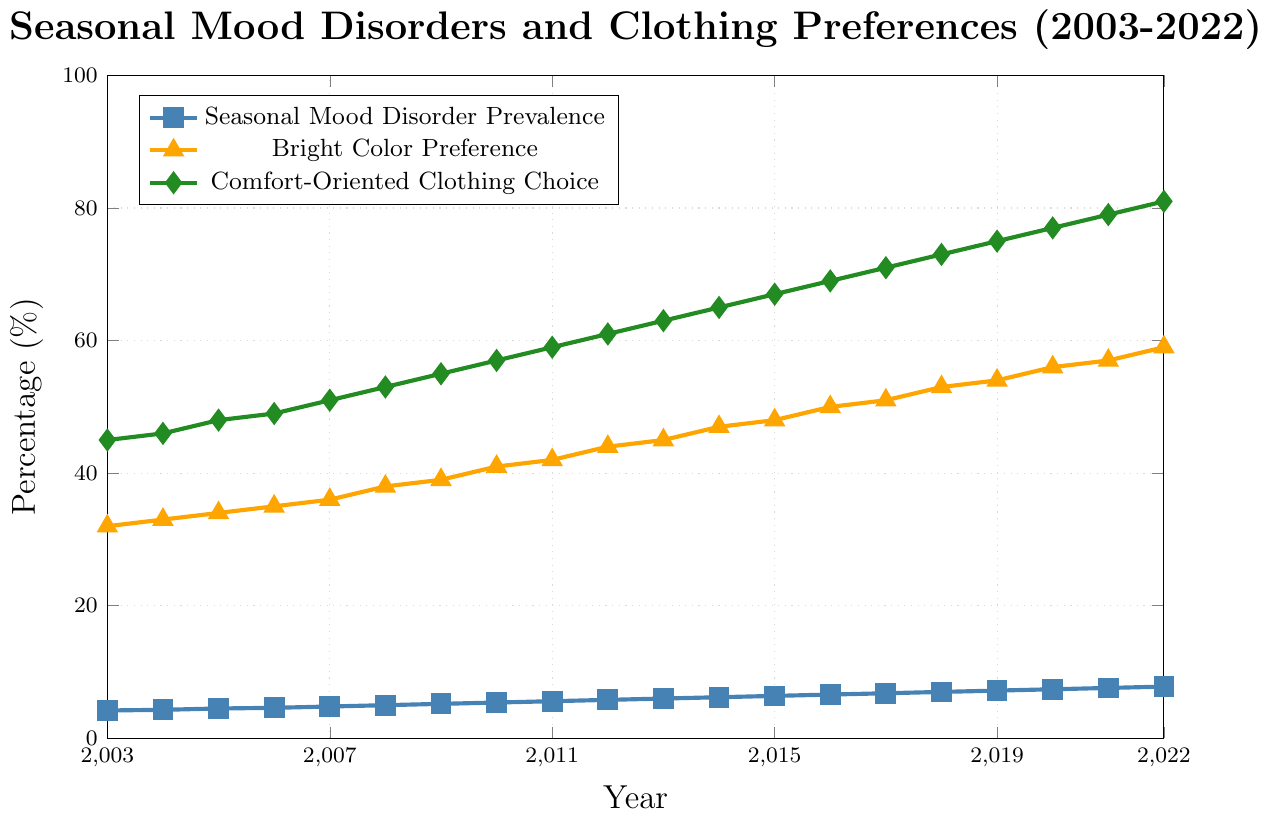What trend can be observed in the prevalence of Seasonal Mood Disorders from 2003 to 2022? The line representing Seasonal Mood Disorder Prevalence shows a steady upward trend from 4.2% in 2003 to 7.8% in 2022, indicating an increase over 20 years.
Answer: It has increased How does the preference for bright colors change over the years 2003 to 2022? The line representing Bright Color Preference generally rises from 32% in 2003 to 59% in 2022, demonstrating an overall increase over the years.
Answer: It has increased In which year was the prevalence of Seasonal Mood Disorders first observed to be above 6%? The line for Seasonal Mood Disorder Prevalence crosses the 6% mark in 2013. This is observed at the point labeled as 2013 on the x-axis.
Answer: 2013 Compare the percentage increase in Comfort-Oriented Clothing Choices and Bright Color Preference between 2003 and 2022. The percentage for Comfort-Oriented Clothing Choices increased from 45% in 2003 to 81% in 2022, an increase of 36 percentage points. Bright Color Preference increased from 32% in 2003 to 59% in 2022, an increase of 27 percentage points.
Answer: 36% (Comfort-Oriented Clothing Choices) and 27% (Bright Color Preference) Which preference (Bright Colors or Comfort-Oriented Clothing) showed a larger overall increase in percentage between 2003 and 2022? Bright Color Preference increased by 27 percentage points (from 32% to 59%), while Comfort-Oriented Clothing Choices increased by 36 percentage points (from 45% to 81%). Comfort-Oriented Clothing showed a larger increase.
Answer: Comfort-Oriented Clothing What is the approximate average percentage of Seasonal Mood Disorders over the two decades shown? Sum the yearly percentages from 2003 to 2022 (total is approximately 113.7%), then divide by 20 years. Thus, 113.7% / 20 ≈ 5.685%.
Answer: Approximately 5.69% In which year did both Bright Color Preference and Comfort-Oriented Clothing Choice cross the 50% threshold? The figure shows that Bright Color Preference crossed the 50% threshold in 2016, and Comfort-Oriented Clothing Choice did so in 2009.
Answer: Bright Color Preference: 2016, Comfort-Oriented Clothing: 2009 How did the increase in Seasonal Mood Disorder prevalence compare to the increase in Comfort-Oriented Clothing Choice over the 20 years? Seasonal Mood Disorders increased from 4.2% to 7.8%, an increase of 3.6 percentage points, while Comfort-Oriented Clothing Choice increased from 45% to 81%, an increase of 36 percentage points.
Answer: 3.6% vs 36% 